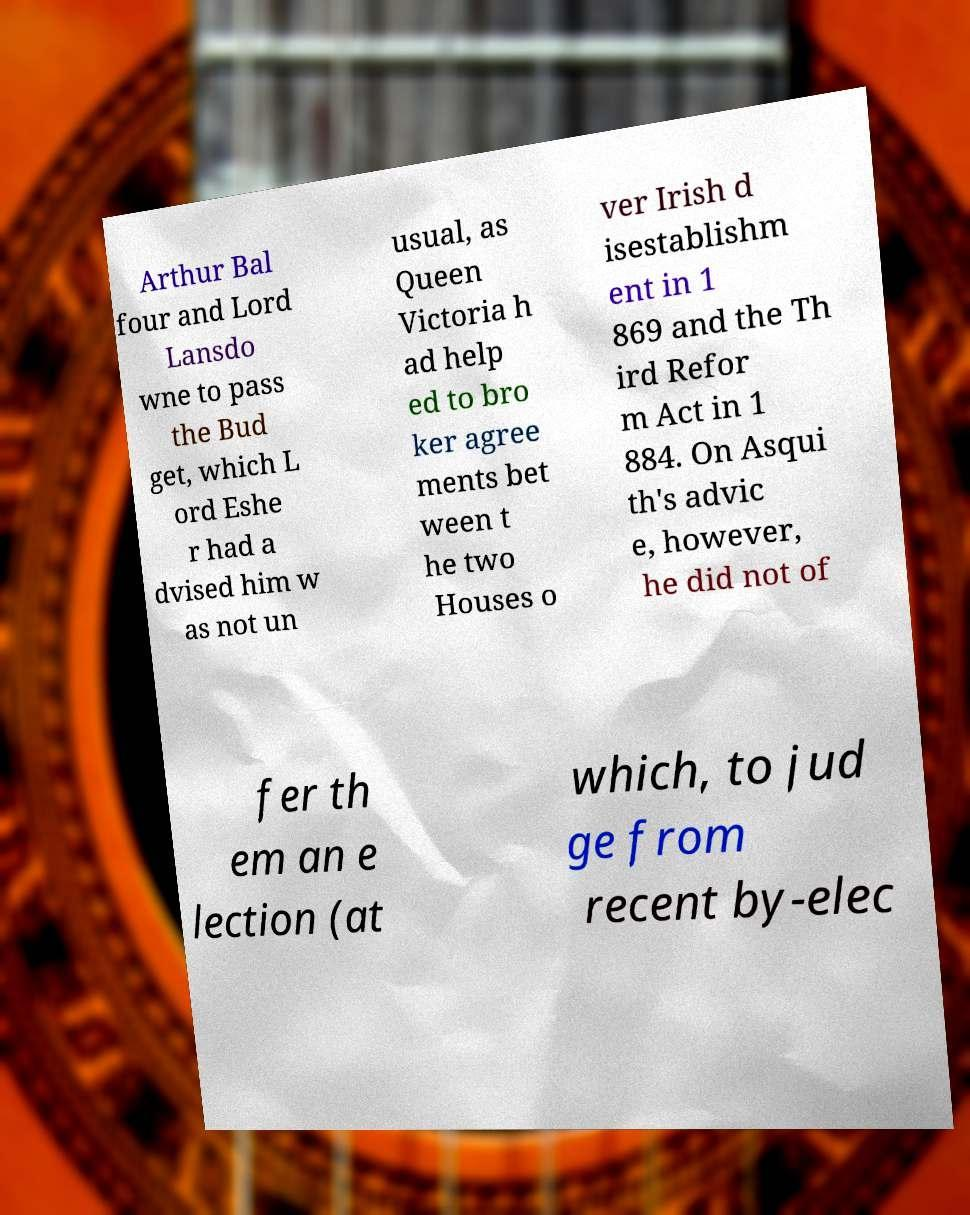Can you read and provide the text displayed in the image?This photo seems to have some interesting text. Can you extract and type it out for me? Arthur Bal four and Lord Lansdo wne to pass the Bud get, which L ord Eshe r had a dvised him w as not un usual, as Queen Victoria h ad help ed to bro ker agree ments bet ween t he two Houses o ver Irish d isestablishm ent in 1 869 and the Th ird Refor m Act in 1 884. On Asqui th's advic e, however, he did not of fer th em an e lection (at which, to jud ge from recent by-elec 